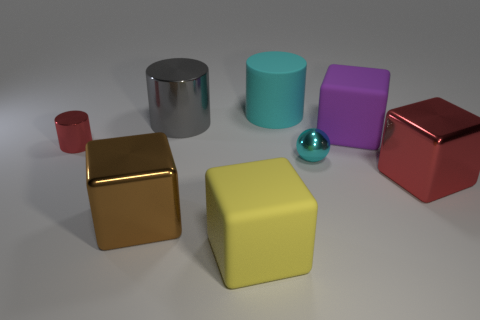There is a large matte block behind the brown shiny cube; is its color the same as the large metal object that is right of the yellow thing?
Give a very brief answer. No. What number of other objects are there of the same shape as the small cyan object?
Keep it short and to the point. 0. Are there any tiny cylinders?
Ensure brevity in your answer.  Yes. What number of objects are either tiny blue balls or metallic objects to the right of the purple thing?
Your answer should be very brief. 1. There is a matte block that is in front of the purple rubber cube; does it have the same size as the large brown cube?
Give a very brief answer. Yes. How many other things are there of the same size as the gray object?
Your answer should be compact. 5. The tiny metallic cylinder has what color?
Provide a succinct answer. Red. What is the cylinder on the right side of the large yellow matte cube made of?
Keep it short and to the point. Rubber. Is the number of small objects that are left of the big cyan cylinder the same as the number of metallic objects?
Your answer should be very brief. No. Is the shape of the big red object the same as the large brown metal object?
Offer a terse response. Yes. 